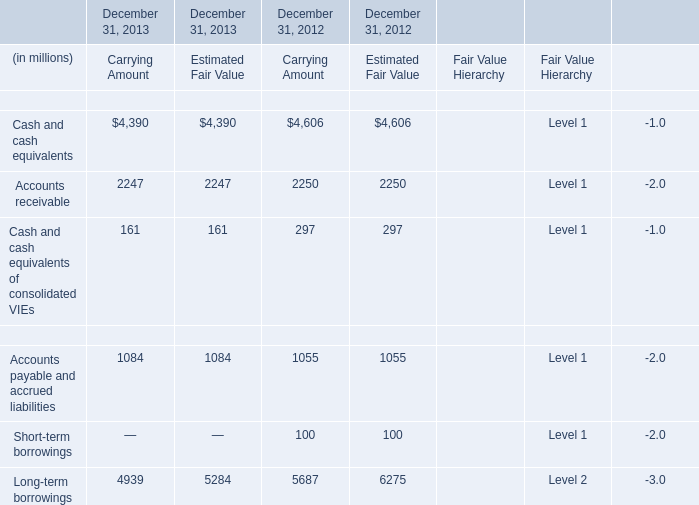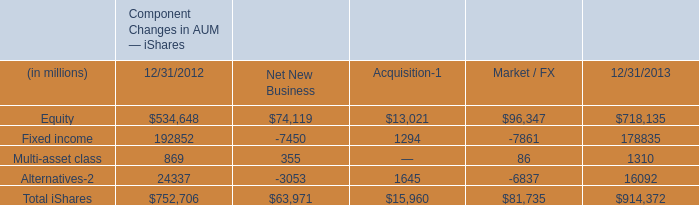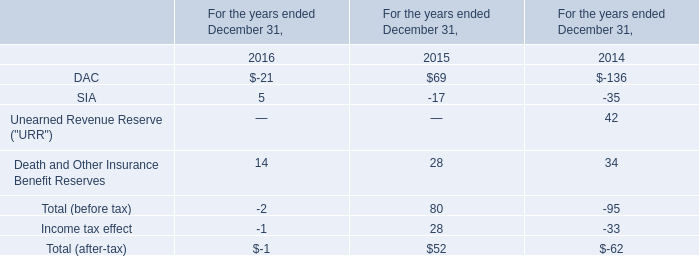What is the average amount of Equity of Component Changes in AUM — iShares 12/31/2012, and Accounts receivable of December 31, 2013 Estimated Fair Value ? 
Computations: ((534648.0 + 2247.0) / 2)
Answer: 268447.5. 